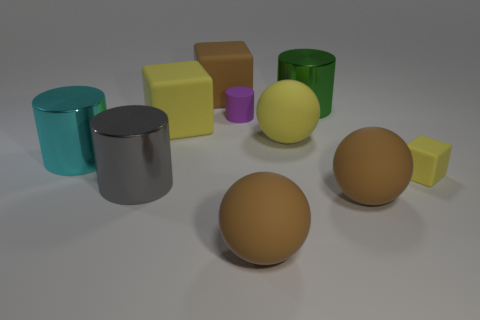Subtract all brown cylinders. Subtract all cyan balls. How many cylinders are left? 4 Subtract all spheres. How many objects are left? 7 Subtract all large cyan things. Subtract all big yellow things. How many objects are left? 7 Add 2 green shiny objects. How many green shiny objects are left? 3 Add 6 big gray metallic things. How many big gray metallic things exist? 7 Subtract 0 blue cubes. How many objects are left? 10 